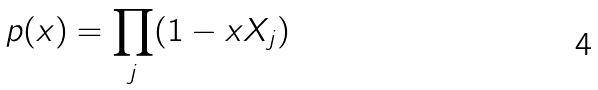<formula> <loc_0><loc_0><loc_500><loc_500>p ( x ) = \prod _ { j } ( 1 - x X _ { j } )</formula> 